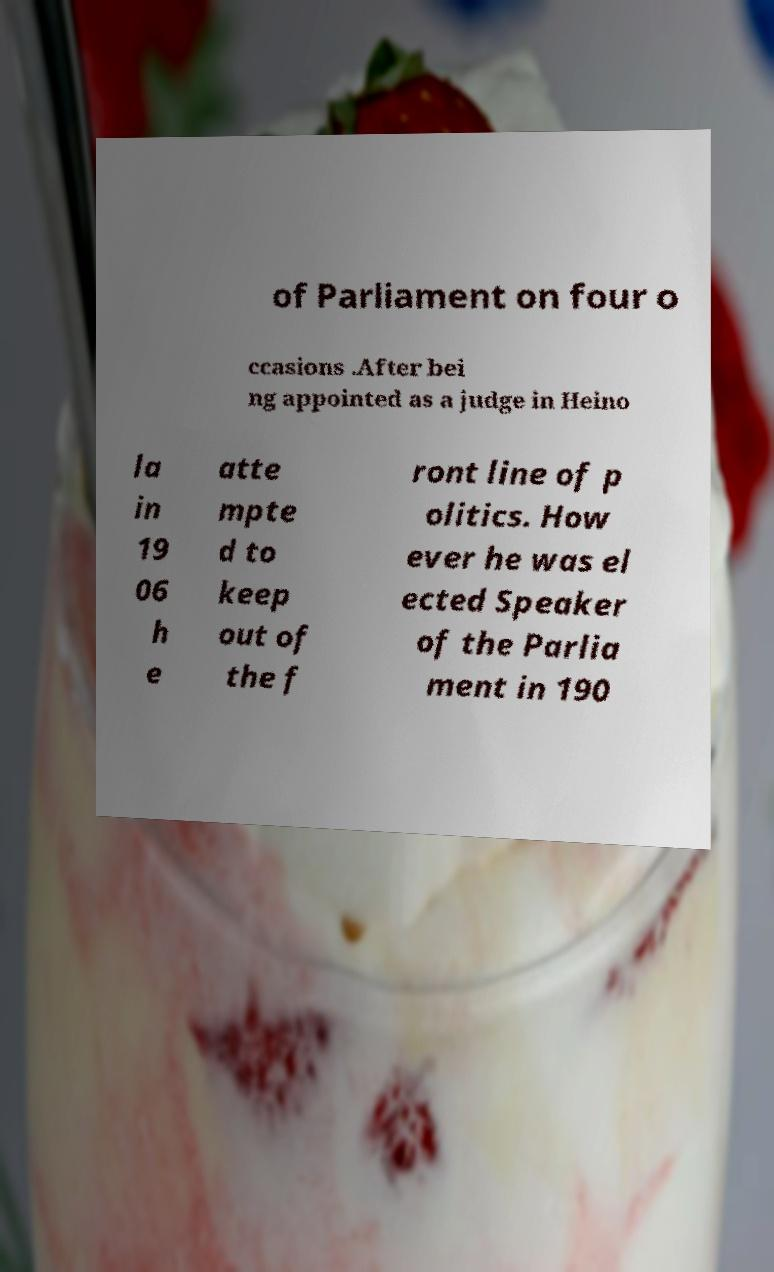Please read and relay the text visible in this image. What does it say? of Parliament on four o ccasions .After bei ng appointed as a judge in Heino la in 19 06 h e atte mpte d to keep out of the f ront line of p olitics. How ever he was el ected Speaker of the Parlia ment in 190 